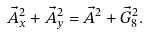<formula> <loc_0><loc_0><loc_500><loc_500>\vec { A } _ { x } ^ { 2 } + \vec { A } _ { y } ^ { 2 } = \vec { A } ^ { 2 } + \vec { G } _ { 8 } ^ { 2 } .</formula> 